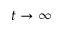<formula> <loc_0><loc_0><loc_500><loc_500>t \rightarrow \infty</formula> 